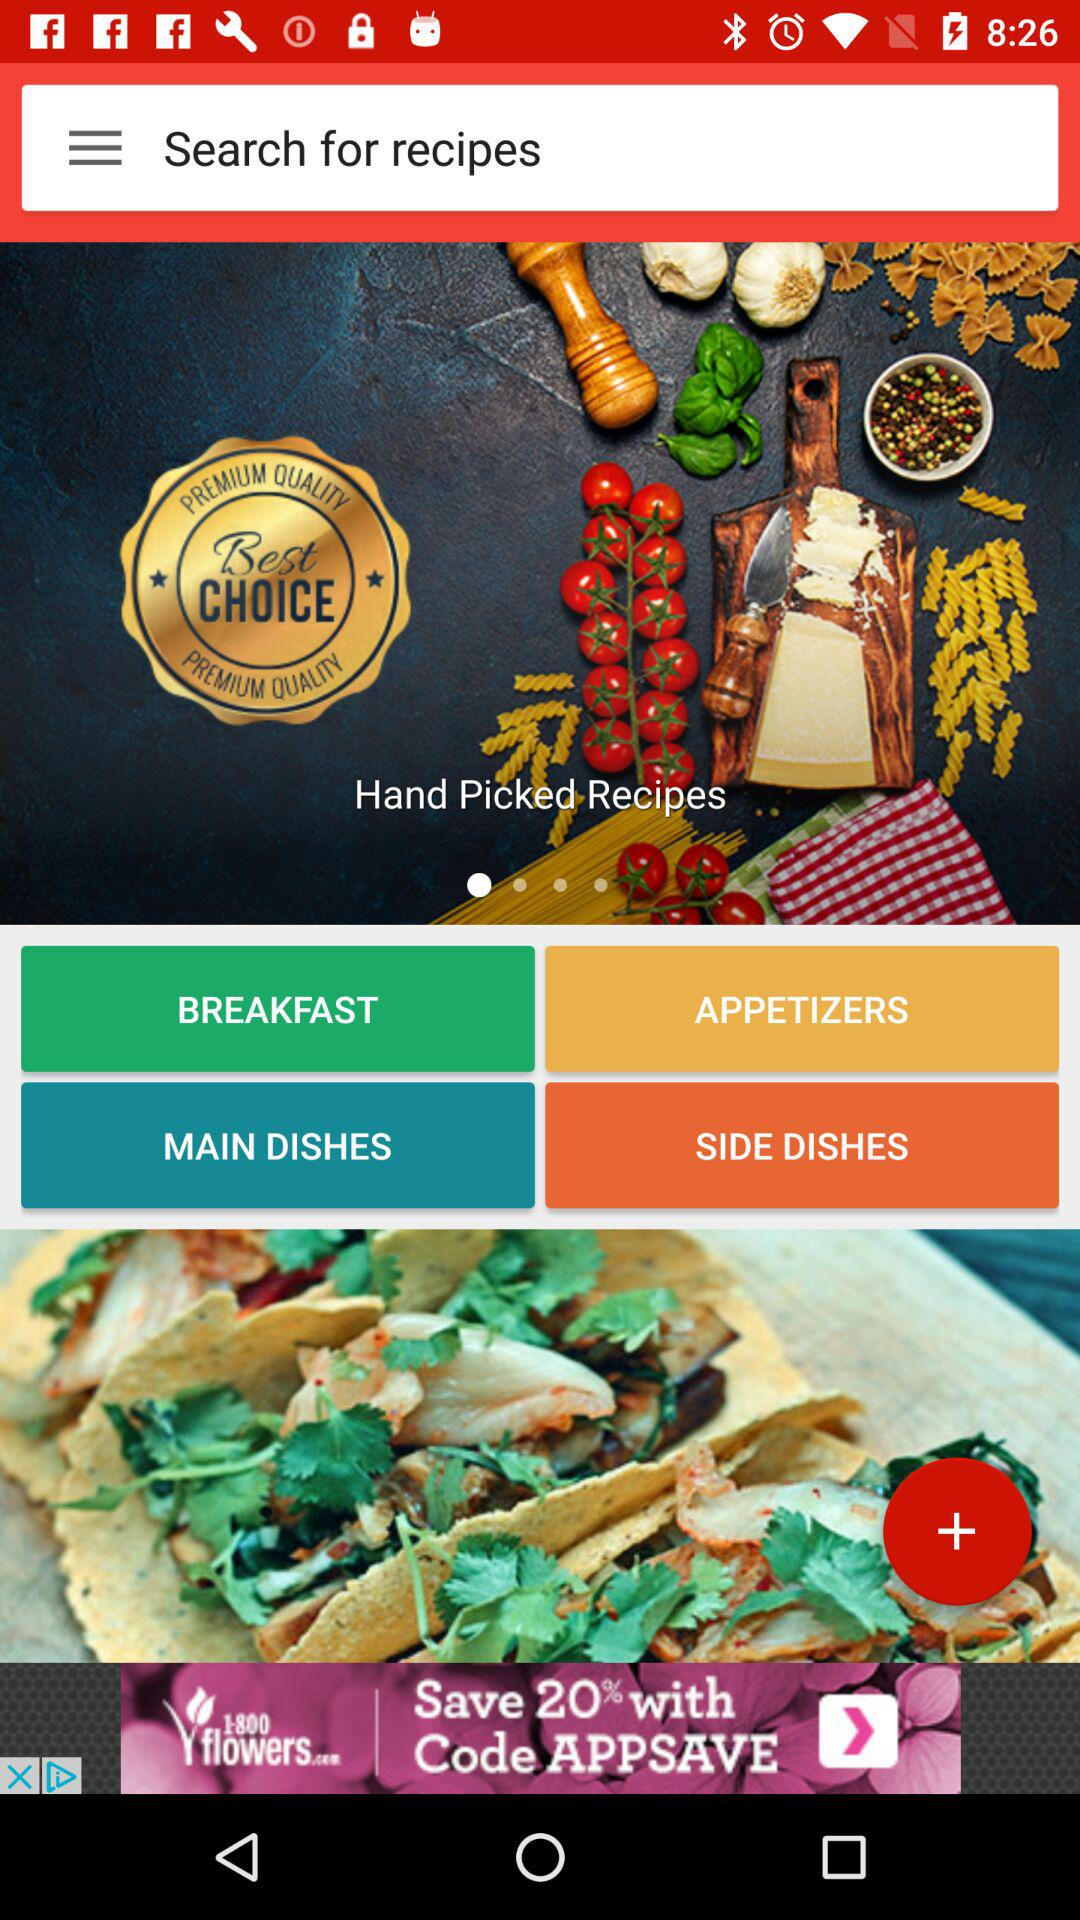What are the hand-picked recipes?
When the provided information is insufficient, respond with <no answer>. <no answer> 